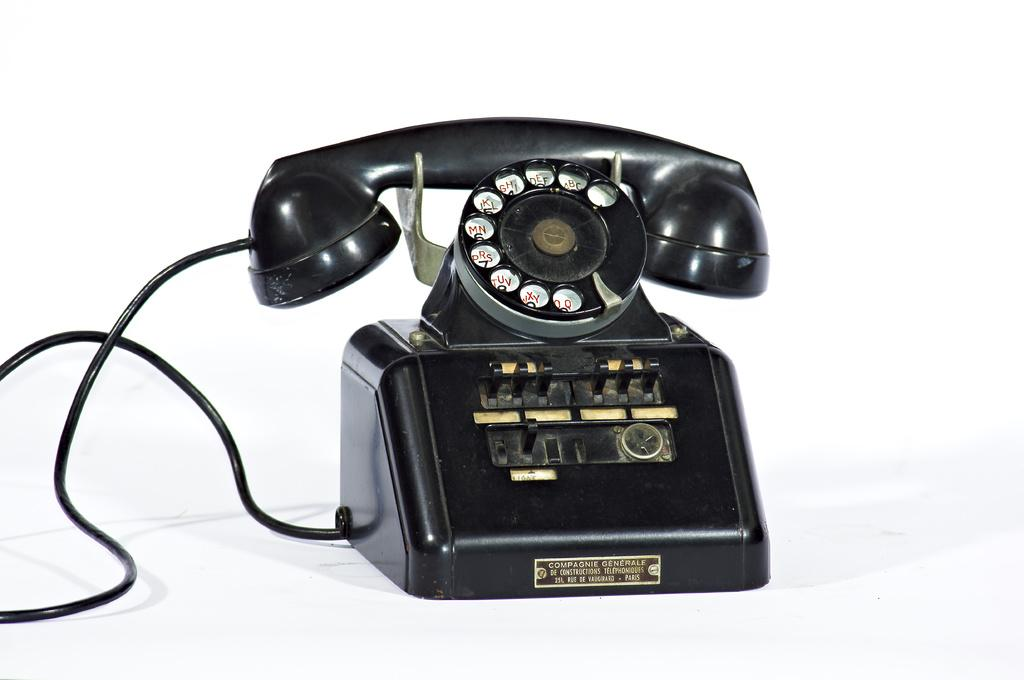What object can be seen in the image? There is a telephone in the image. How many snakes are slithering on the road in the image? There are no snakes or roads present in the image; it only features a telephone. What type of feather can be seen on the telephone in the image? There is no feather present on the telephone in the image. 